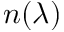Convert formula to latex. <formula><loc_0><loc_0><loc_500><loc_500>n ( \lambda )</formula> 